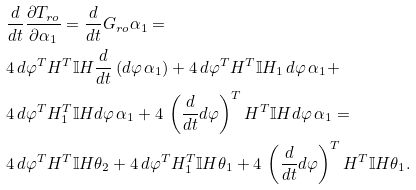Convert formula to latex. <formula><loc_0><loc_0><loc_500><loc_500>& \frac { d } { d t } \frac { \partial T _ { r o } } { \partial \alpha _ { 1 } } = \frac { d } { d t } G _ { r o } \alpha _ { 1 } = \\ & 4 \, d \varphi ^ { T } H ^ { T } \mathbb { I } H \frac { d } { d t } \left ( d \varphi \, \alpha _ { 1 } \right ) + 4 \, d \varphi ^ { T } H ^ { T } \mathbb { I } H _ { 1 } \, d \varphi \, \alpha _ { 1 } + \\ & 4 \, d \varphi ^ { T } H _ { 1 } ^ { T } \mathbb { I } H d \varphi \, \alpha _ { 1 } + 4 \, \left ( \frac { d } { d t } d \varphi \right ) ^ { T } H ^ { T } \mathbb { I } H d \varphi \, \alpha _ { 1 } = \\ & 4 \, d \varphi ^ { T } H ^ { T } \mathbb { I } H \theta _ { 2 } + 4 \, d \varphi ^ { T } H _ { 1 } ^ { T } \mathbb { I } H \theta _ { 1 } + 4 \, \left ( \frac { d } { d t } d \varphi \right ) ^ { T } H ^ { T } \mathbb { I } H \theta _ { 1 } .</formula> 